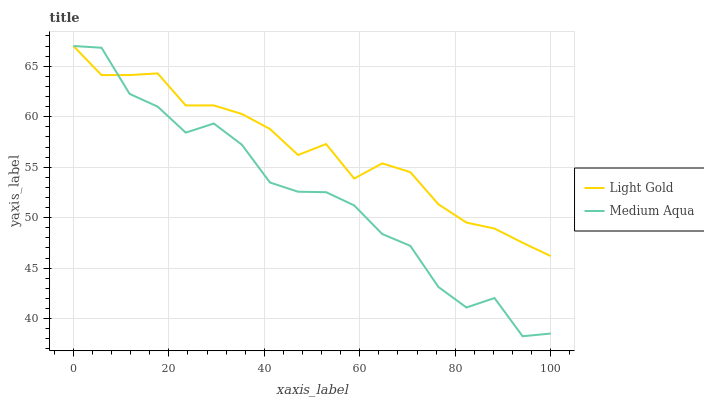Does Medium Aqua have the minimum area under the curve?
Answer yes or no. Yes. Does Light Gold have the maximum area under the curve?
Answer yes or no. Yes. Does Light Gold have the minimum area under the curve?
Answer yes or no. No. Is Light Gold the smoothest?
Answer yes or no. Yes. Is Medium Aqua the roughest?
Answer yes or no. Yes. Is Light Gold the roughest?
Answer yes or no. No. Does Medium Aqua have the lowest value?
Answer yes or no. Yes. Does Light Gold have the lowest value?
Answer yes or no. No. Does Light Gold have the highest value?
Answer yes or no. Yes. Does Medium Aqua intersect Light Gold?
Answer yes or no. Yes. Is Medium Aqua less than Light Gold?
Answer yes or no. No. Is Medium Aqua greater than Light Gold?
Answer yes or no. No. 